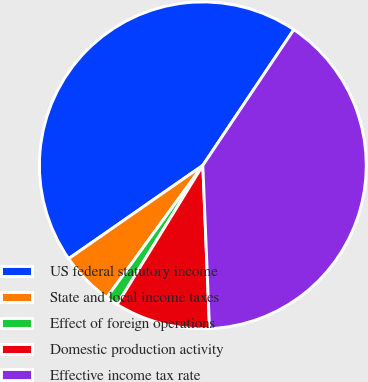Convert chart. <chart><loc_0><loc_0><loc_500><loc_500><pie_chart><fcel>US federal statutory income<fcel>State and local income taxes<fcel>Effect of foreign operations<fcel>Domestic production activity<fcel>Effective income tax rate<nl><fcel>44.07%<fcel>5.33%<fcel>1.21%<fcel>9.44%<fcel>39.95%<nl></chart> 